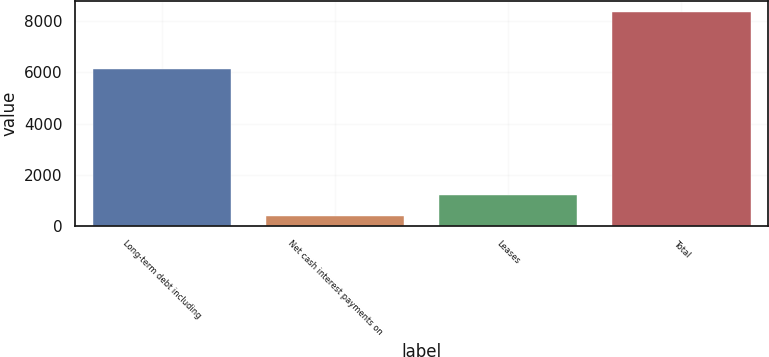Convert chart to OTSL. <chart><loc_0><loc_0><loc_500><loc_500><bar_chart><fcel>Long-term debt including<fcel>Net cash interest payments on<fcel>Leases<fcel>Total<nl><fcel>6132<fcel>398<fcel>1194.9<fcel>8367<nl></chart> 